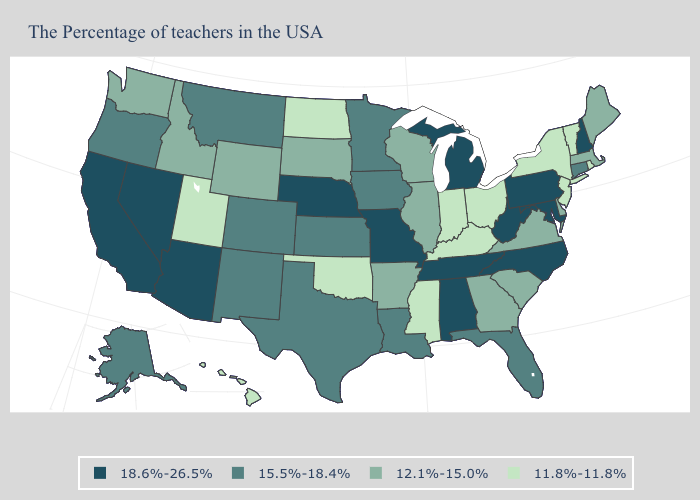What is the value of Ohio?
Be succinct. 11.8%-11.8%. Does the first symbol in the legend represent the smallest category?
Be succinct. No. Name the states that have a value in the range 11.8%-11.8%?
Short answer required. Rhode Island, Vermont, New York, New Jersey, Ohio, Kentucky, Indiana, Mississippi, Oklahoma, North Dakota, Utah, Hawaii. What is the value of Alaska?
Concise answer only. 15.5%-18.4%. Among the states that border Washington , which have the highest value?
Short answer required. Oregon. Name the states that have a value in the range 12.1%-15.0%?
Keep it brief. Maine, Massachusetts, Delaware, Virginia, South Carolina, Georgia, Wisconsin, Illinois, Arkansas, South Dakota, Wyoming, Idaho, Washington. What is the value of Maryland?
Write a very short answer. 18.6%-26.5%. Among the states that border Kansas , does Nebraska have the highest value?
Give a very brief answer. Yes. Is the legend a continuous bar?
Write a very short answer. No. Name the states that have a value in the range 18.6%-26.5%?
Quick response, please. New Hampshire, Maryland, Pennsylvania, North Carolina, West Virginia, Michigan, Alabama, Tennessee, Missouri, Nebraska, Arizona, Nevada, California. What is the value of Indiana?
Concise answer only. 11.8%-11.8%. Which states have the highest value in the USA?
Write a very short answer. New Hampshire, Maryland, Pennsylvania, North Carolina, West Virginia, Michigan, Alabama, Tennessee, Missouri, Nebraska, Arizona, Nevada, California. Name the states that have a value in the range 11.8%-11.8%?
Concise answer only. Rhode Island, Vermont, New York, New Jersey, Ohio, Kentucky, Indiana, Mississippi, Oklahoma, North Dakota, Utah, Hawaii. Which states have the lowest value in the MidWest?
Keep it brief. Ohio, Indiana, North Dakota. Name the states that have a value in the range 11.8%-11.8%?
Give a very brief answer. Rhode Island, Vermont, New York, New Jersey, Ohio, Kentucky, Indiana, Mississippi, Oklahoma, North Dakota, Utah, Hawaii. 